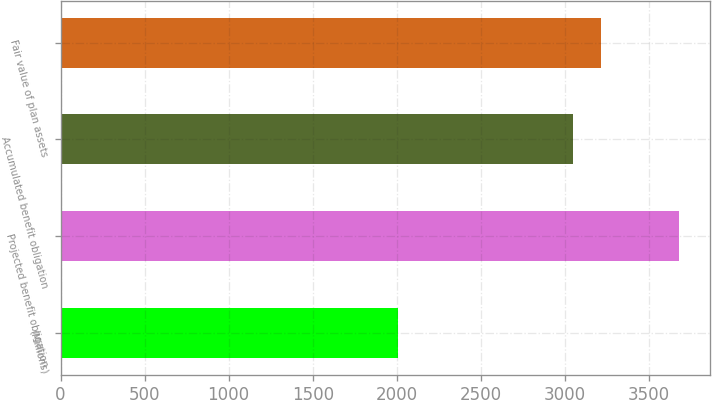Convert chart to OTSL. <chart><loc_0><loc_0><loc_500><loc_500><bar_chart><fcel>(Millions)<fcel>Projected benefit obligation<fcel>Accumulated benefit obligation<fcel>Fair value of plan assets<nl><fcel>2006<fcel>3680<fcel>3049<fcel>3216.4<nl></chart> 